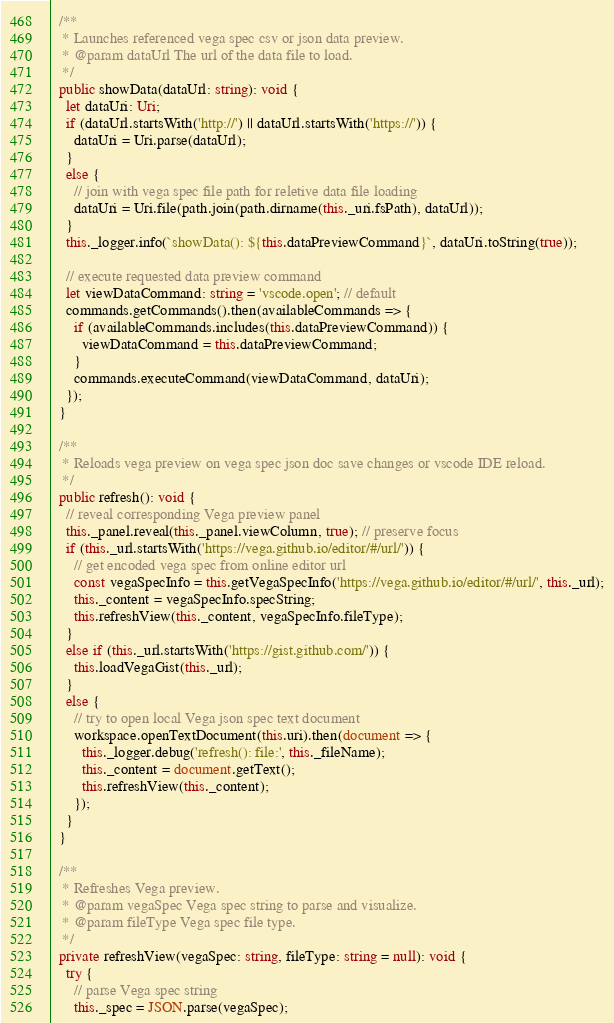<code> <loc_0><loc_0><loc_500><loc_500><_TypeScript_>
  /**
   * Launches referenced vega spec csv or json data preview.
   * @param dataUrl The url of the data file to load.
   */
  public showData(dataUrl: string): void {
    let dataUri: Uri;
    if (dataUrl.startsWith('http://') || dataUrl.startsWith('https://')) {
      dataUri = Uri.parse(dataUrl);
    }
    else { 
      // join with vega spec file path for reletive data file loading
      dataUri = Uri.file(path.join(path.dirname(this._uri.fsPath), dataUrl));
    }
    this._logger.info(`showData(): ${this.dataPreviewCommand}`, dataUri.toString(true));
    
    // execute requested data preview command
    let viewDataCommand: string = 'vscode.open'; // default
    commands.getCommands().then(availableCommands => {
      if (availableCommands.includes(this.dataPreviewCommand)) {
        viewDataCommand = this.dataPreviewCommand;
      }
      commands.executeCommand(viewDataCommand, dataUri);
    });
  }

  /**
   * Reloads vega preview on vega spec json doc save changes or vscode IDE reload.
   */
  public refresh(): void {
    // reveal corresponding Vega preview panel
    this._panel.reveal(this._panel.viewColumn, true); // preserve focus
    if (this._url.startsWith('https://vega.github.io/editor/#/url/')) {
      // get encoded vega spec from online editor url
      const vegaSpecInfo = this.getVegaSpecInfo('https://vega.github.io/editor/#/url/', this._url);
      this._content = vegaSpecInfo.specString;
      this.refreshView(this._content, vegaSpecInfo.fileType);
    }
    else if (this._url.startsWith('https://gist.github.com/')) {
      this.loadVegaGist(this._url);
    }
    else {
      // try to open local Vega json spec text document
      workspace.openTextDocument(this.uri).then(document => {
        this._logger.debug('refresh(): file:', this._fileName);
        this._content = document.getText();
        this.refreshView(this._content);
      });
    }
  }

  /**
   * Refreshes Vega preview.
   * @param vegaSpec Vega spec string to parse and visualize.
   * @param fileType Vega spec file type.
   */
  private refreshView(vegaSpec: string, fileType: string = null): void {
    try {
      // parse Vega spec string
      this._spec = JSON.parse(vegaSpec);
</code> 